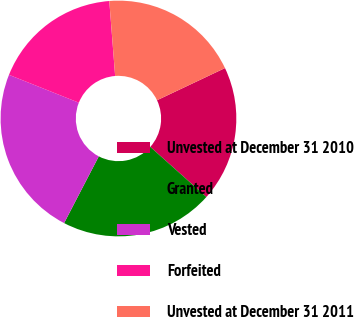<chart> <loc_0><loc_0><loc_500><loc_500><pie_chart><fcel>Unvested at December 31 2010<fcel>Granted<fcel>Vested<fcel>Forfeited<fcel>Unvested at December 31 2011<nl><fcel>18.63%<fcel>21.03%<fcel>23.41%<fcel>17.72%<fcel>19.2%<nl></chart> 